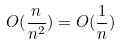<formula> <loc_0><loc_0><loc_500><loc_500>O ( \frac { n } { n ^ { 2 } } ) = O ( \frac { 1 } { n } )</formula> 